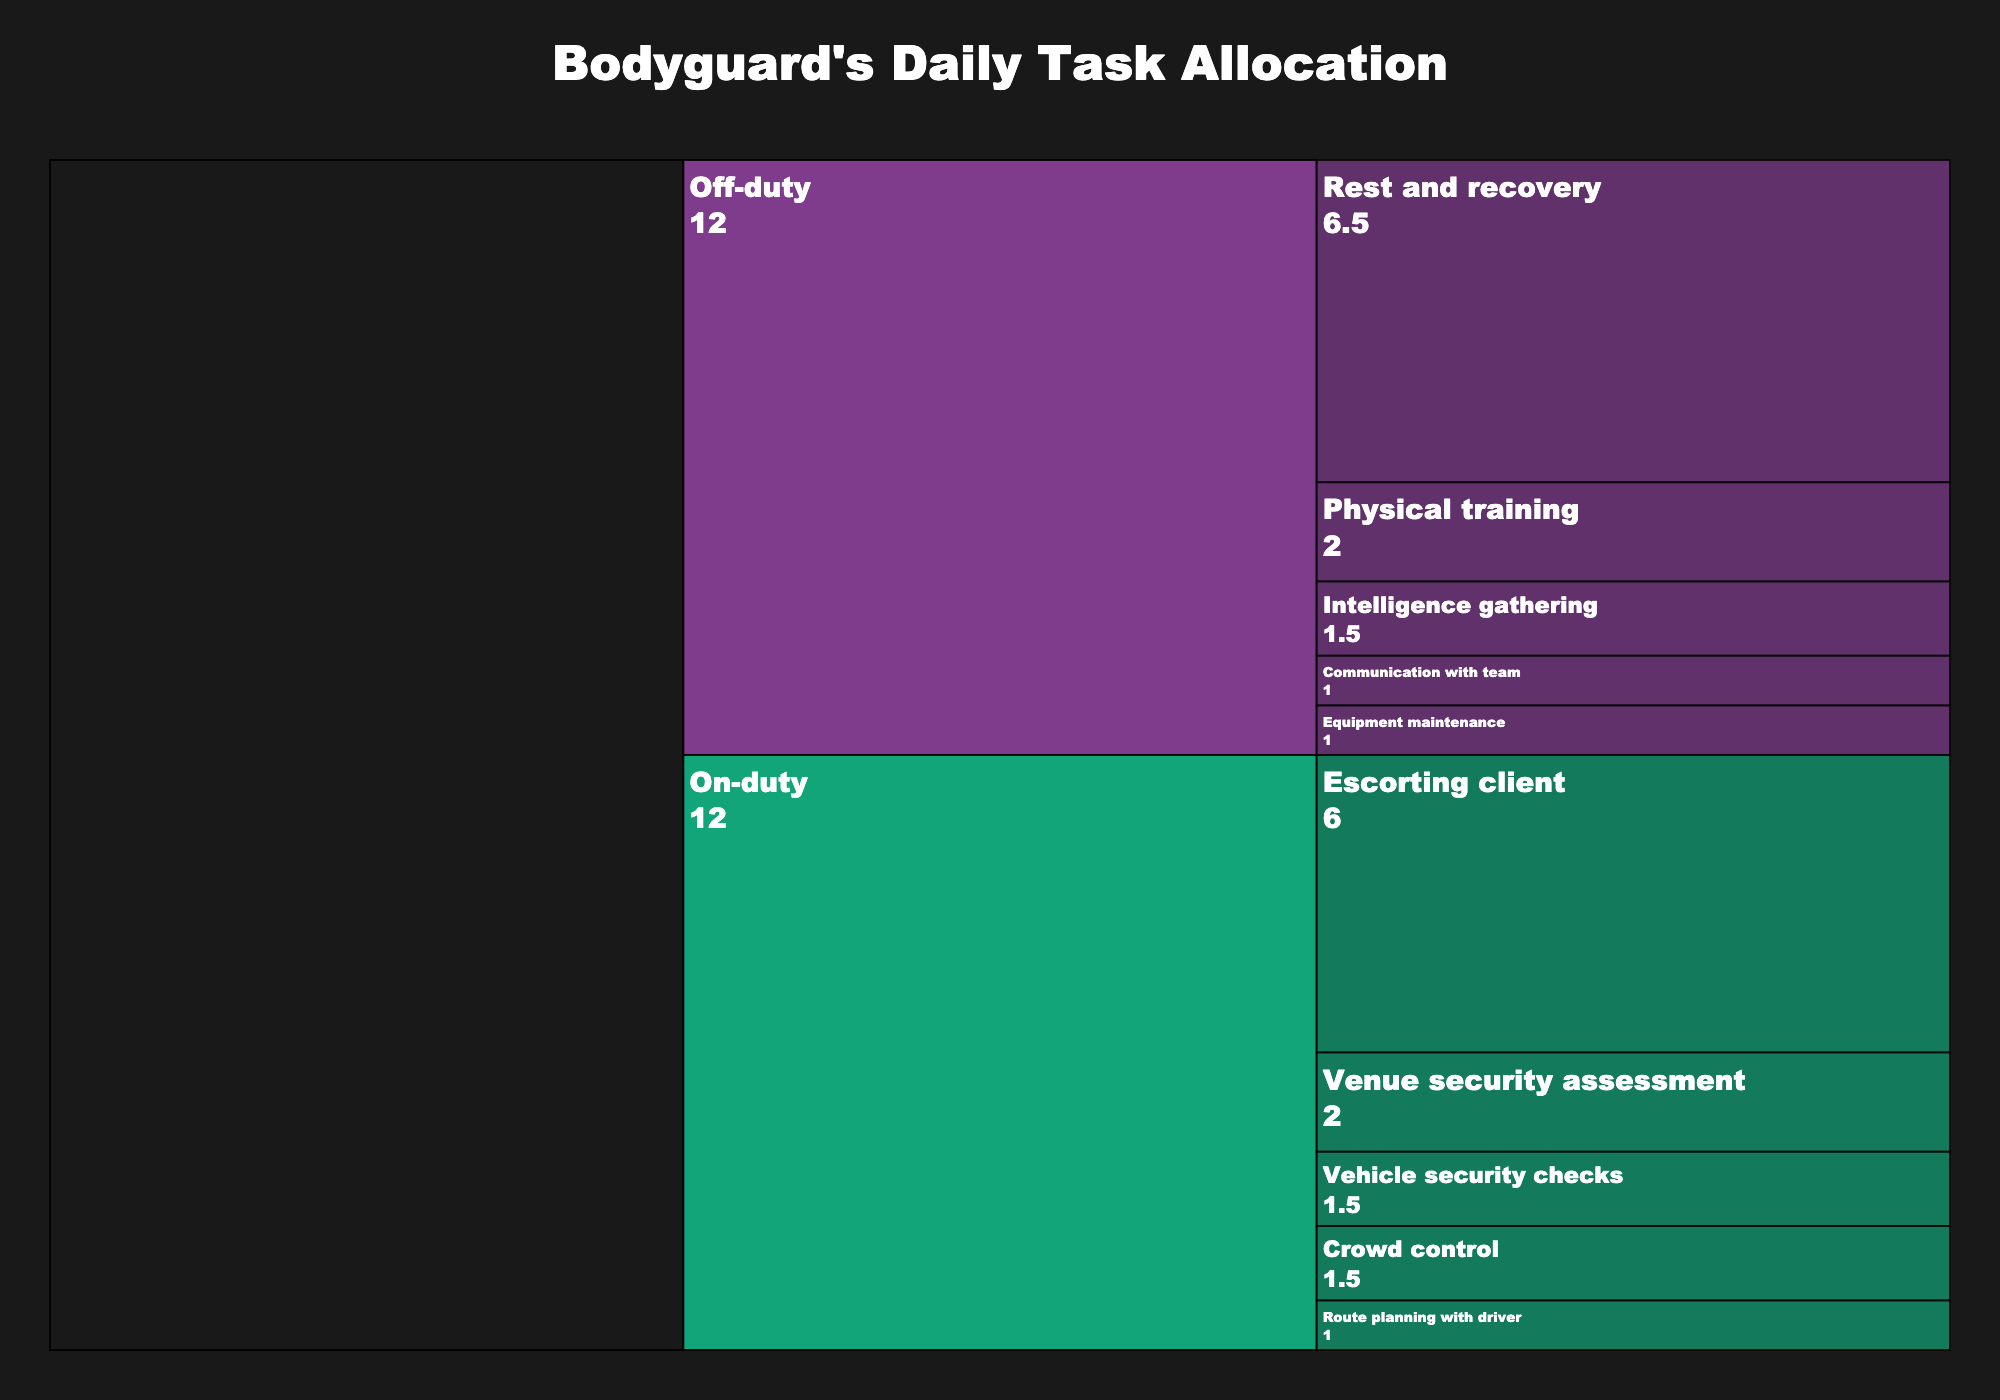What's the title of the chart? The title is usually displayed prominently, typically at the top of the chart. In this figure, the title is "Bodyguard's Daily Task Allocation".
Answer: Bodyguard's Daily Task Allocation How many total hours are spent on 'On-duty' tasks? To find the total time spent on 'On-duty' tasks, sum up all the hours under the 'On-duty' category. 1.5 + 1 + 6 + 2 + 1.5 = 12 hours.
Answer: 12 hours Which 'Subtask' takes up the most time during 'Off-duty'? Look at the 'Off-duty' section and identify the subtask with the largest time allocation. 'Rest and recovery' has the highest value of 6.5 hours.
Answer: Rest and recovery How much more time is spent on 'Escorting client' compared to 'Physical training'? 'Escorting client' is 6 hours and 'Physical training' is 2 hours. The difference is 6 - 2 = 4 hours.
Answer: 4 hours What is the combined time for 'Vehicle security checks' and 'Route planning with driver'? Add the times for 'Vehicle security checks' (1.5 hours) and 'Route planning with driver' (1 hour). 1.5 + 1 = 2.5 hours.
Answer: 2.5 hours Compare the time spent on 'Communication with team' and 'Equipment maintenance'. Which one is longer and by how much? Both 'Communication with team' and 'Equipment maintenance' are 1 hour each, so there is no difference between them.
Answer: 0 hours, both are equal What percentage of the 'Off-duty' time is dedicated to 'Rest and recovery'? The total 'Off-duty' time is the sum of the 'Off-duty' subtasks: 2 + 1.5 + 1 + 1 + 6.5 = 12 hours. The time for 'Rest and recovery' is 6.5 hours. The percentage is (6.5 / 12) * 100 ≈ 54.17%.
Answer: 54.17% What is the average time spent on each 'Off-duty' subtask? There are 5 'Off-duty' subtasks. The total 'Off-duty' time is 12 hours. The average is 12 / 5 = 2.4 hours.
Answer: 2.4 hours If one hour is taken from 'Rest and recovery' and given to 'Intelligence gathering', how will their new values compare? 'Rest and recovery' will be 6.5 - 1 = 5.5 hours, and 'Intelligence gathering' will be 1.5 + 1 = 2.5 hours. 'Rest and recovery' will still have more hours than 'Intelligence gathering', with a difference of 5.5 - 2.5 = 3 hours.
Answer: 3 hours 